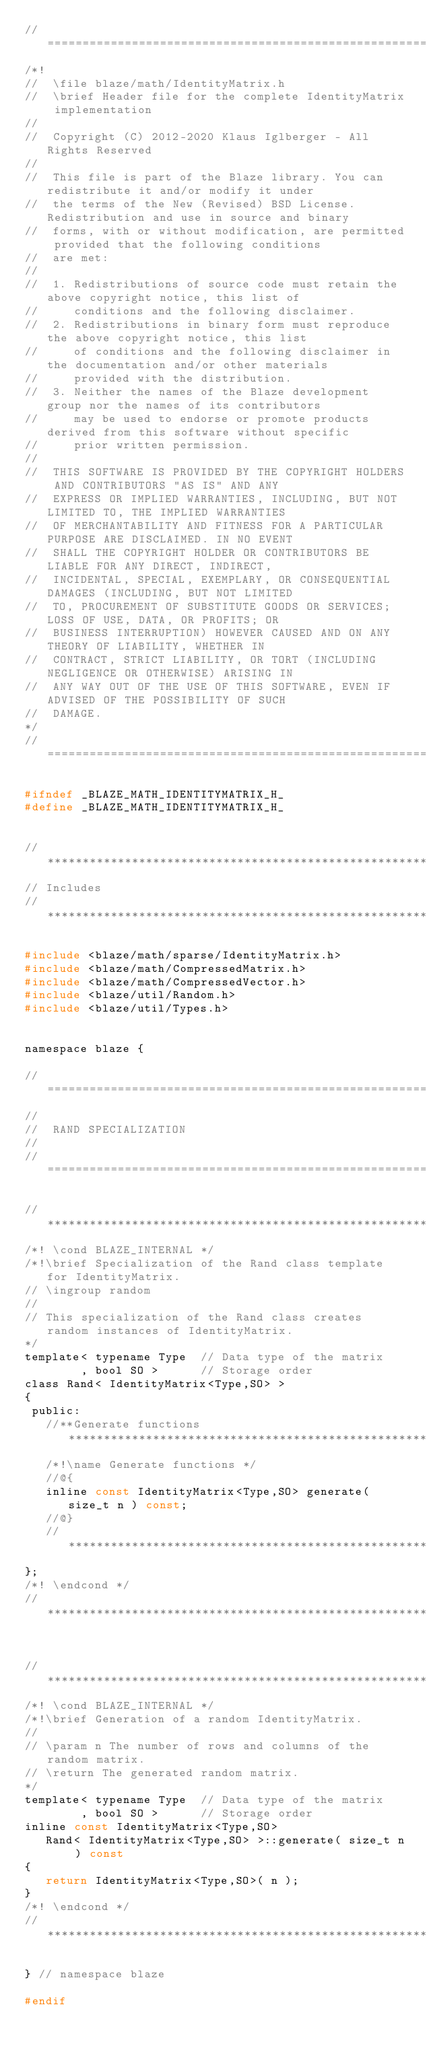Convert code to text. <code><loc_0><loc_0><loc_500><loc_500><_C_>//=================================================================================================
/*!
//  \file blaze/math/IdentityMatrix.h
//  \brief Header file for the complete IdentityMatrix implementation
//
//  Copyright (C) 2012-2020 Klaus Iglberger - All Rights Reserved
//
//  This file is part of the Blaze library. You can redistribute it and/or modify it under
//  the terms of the New (Revised) BSD License. Redistribution and use in source and binary
//  forms, with or without modification, are permitted provided that the following conditions
//  are met:
//
//  1. Redistributions of source code must retain the above copyright notice, this list of
//     conditions and the following disclaimer.
//  2. Redistributions in binary form must reproduce the above copyright notice, this list
//     of conditions and the following disclaimer in the documentation and/or other materials
//     provided with the distribution.
//  3. Neither the names of the Blaze development group nor the names of its contributors
//     may be used to endorse or promote products derived from this software without specific
//     prior written permission.
//
//  THIS SOFTWARE IS PROVIDED BY THE COPYRIGHT HOLDERS AND CONTRIBUTORS "AS IS" AND ANY
//  EXPRESS OR IMPLIED WARRANTIES, INCLUDING, BUT NOT LIMITED TO, THE IMPLIED WARRANTIES
//  OF MERCHANTABILITY AND FITNESS FOR A PARTICULAR PURPOSE ARE DISCLAIMED. IN NO EVENT
//  SHALL THE COPYRIGHT HOLDER OR CONTRIBUTORS BE LIABLE FOR ANY DIRECT, INDIRECT,
//  INCIDENTAL, SPECIAL, EXEMPLARY, OR CONSEQUENTIAL DAMAGES (INCLUDING, BUT NOT LIMITED
//  TO, PROCUREMENT OF SUBSTITUTE GOODS OR SERVICES; LOSS OF USE, DATA, OR PROFITS; OR
//  BUSINESS INTERRUPTION) HOWEVER CAUSED AND ON ANY THEORY OF LIABILITY, WHETHER IN
//  CONTRACT, STRICT LIABILITY, OR TORT (INCLUDING NEGLIGENCE OR OTHERWISE) ARISING IN
//  ANY WAY OUT OF THE USE OF THIS SOFTWARE, EVEN IF ADVISED OF THE POSSIBILITY OF SUCH
//  DAMAGE.
*/
//=================================================================================================

#ifndef _BLAZE_MATH_IDENTITYMATRIX_H_
#define _BLAZE_MATH_IDENTITYMATRIX_H_


//*************************************************************************************************
// Includes
//*************************************************************************************************

#include <blaze/math/sparse/IdentityMatrix.h>
#include <blaze/math/CompressedMatrix.h>
#include <blaze/math/CompressedVector.h>
#include <blaze/util/Random.h>
#include <blaze/util/Types.h>


namespace blaze {

//=================================================================================================
//
//  RAND SPECIALIZATION
//
//=================================================================================================

//*************************************************************************************************
/*! \cond BLAZE_INTERNAL */
/*!\brief Specialization of the Rand class template for IdentityMatrix.
// \ingroup random
//
// This specialization of the Rand class creates random instances of IdentityMatrix.
*/
template< typename Type  // Data type of the matrix
        , bool SO >      // Storage order
class Rand< IdentityMatrix<Type,SO> >
{
 public:
   //**Generate functions**************************************************************************
   /*!\name Generate functions */
   //@{
   inline const IdentityMatrix<Type,SO> generate( size_t n ) const;
   //@}
   //**********************************************************************************************
};
/*! \endcond */
//*************************************************************************************************


//*************************************************************************************************
/*! \cond BLAZE_INTERNAL */
/*!\brief Generation of a random IdentityMatrix.
//
// \param n The number of rows and columns of the random matrix.
// \return The generated random matrix.
*/
template< typename Type  // Data type of the matrix
        , bool SO >      // Storage order
inline const IdentityMatrix<Type,SO>
   Rand< IdentityMatrix<Type,SO> >::generate( size_t n ) const
{
   return IdentityMatrix<Type,SO>( n );
}
/*! \endcond */
//*************************************************************************************************

} // namespace blaze

#endif
</code> 